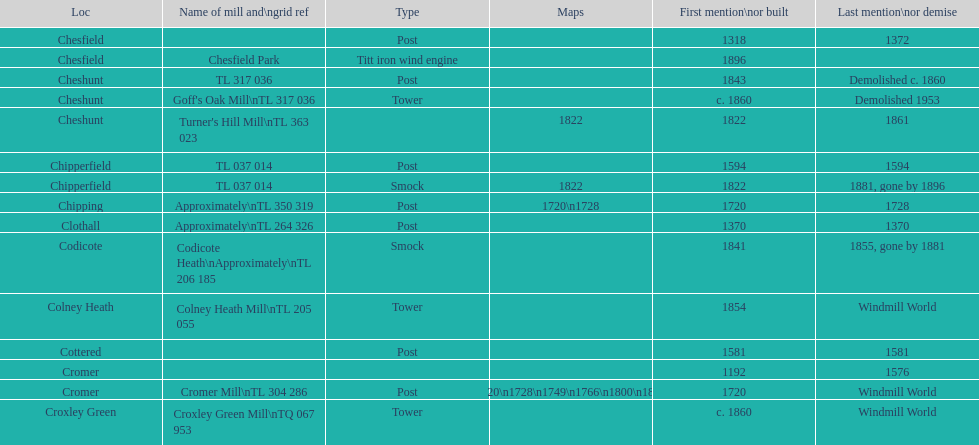What is the name of the only "c" mill located in colney health? Colney Heath Mill. 